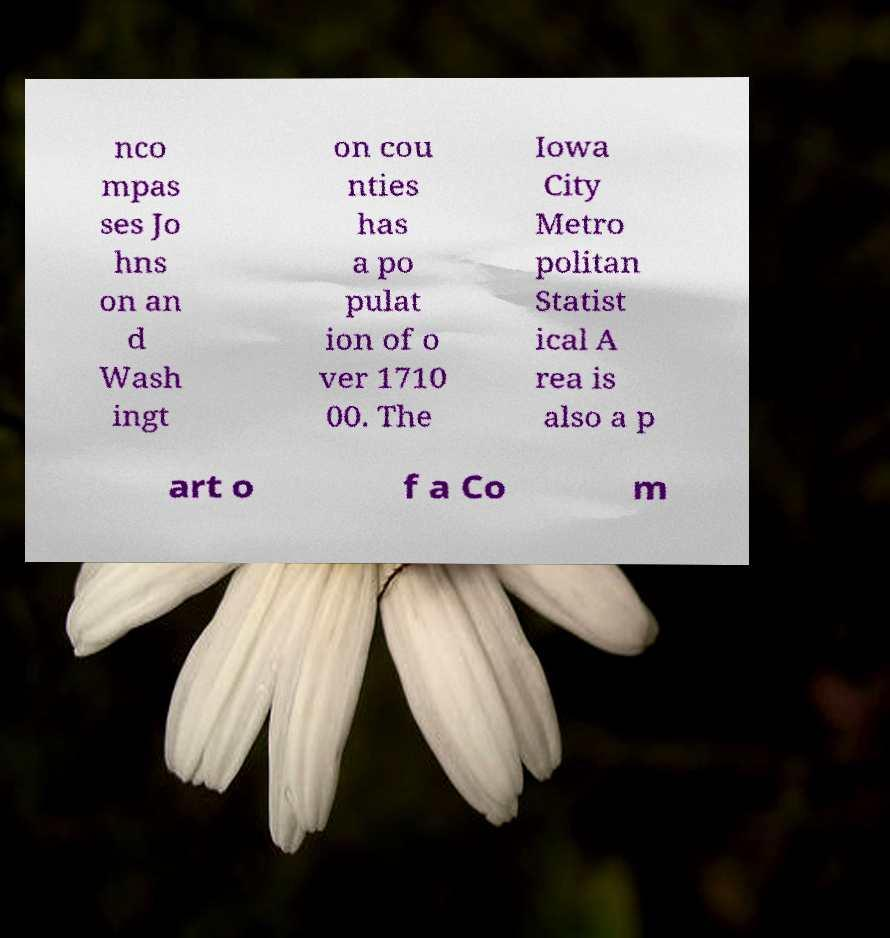For documentation purposes, I need the text within this image transcribed. Could you provide that? nco mpas ses Jo hns on an d Wash ingt on cou nties has a po pulat ion of o ver 1710 00. The Iowa City Metro politan Statist ical A rea is also a p art o f a Co m 